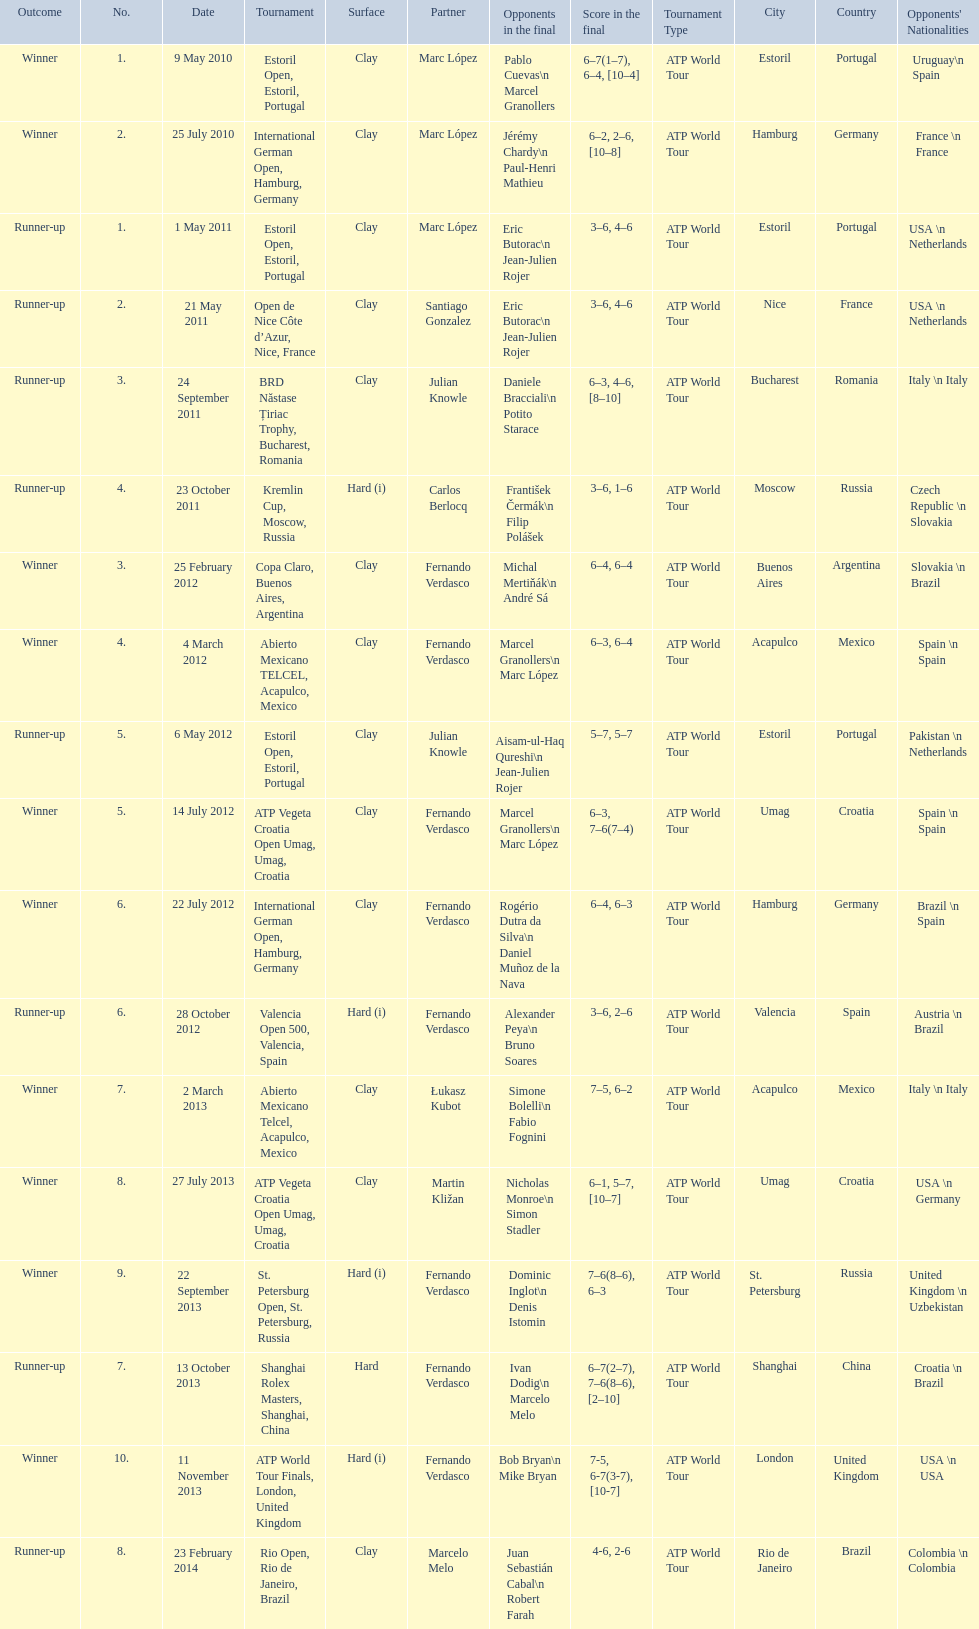How many tournaments has this player won in his career so far? 10. 